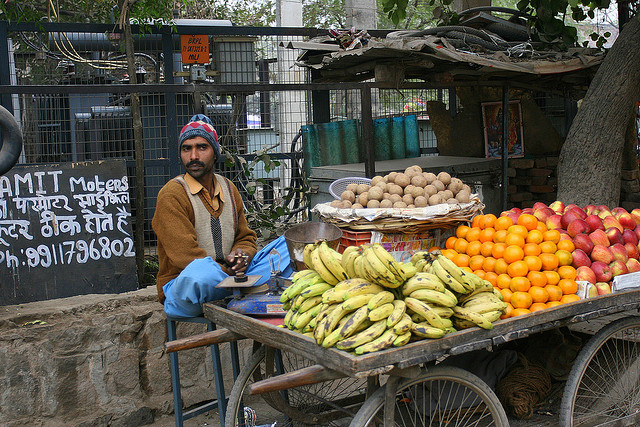Please identify all text content in this image. Ph:9911796802 AMIT MotrRS 